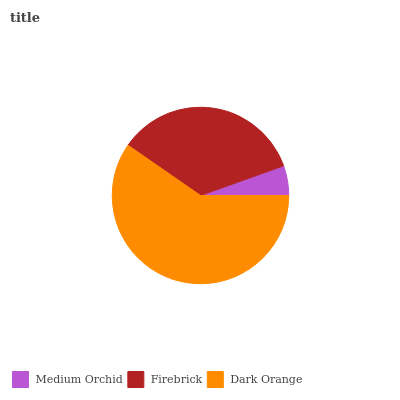Is Medium Orchid the minimum?
Answer yes or no. Yes. Is Dark Orange the maximum?
Answer yes or no. Yes. Is Firebrick the minimum?
Answer yes or no. No. Is Firebrick the maximum?
Answer yes or no. No. Is Firebrick greater than Medium Orchid?
Answer yes or no. Yes. Is Medium Orchid less than Firebrick?
Answer yes or no. Yes. Is Medium Orchid greater than Firebrick?
Answer yes or no. No. Is Firebrick less than Medium Orchid?
Answer yes or no. No. Is Firebrick the high median?
Answer yes or no. Yes. Is Firebrick the low median?
Answer yes or no. Yes. Is Dark Orange the high median?
Answer yes or no. No. Is Dark Orange the low median?
Answer yes or no. No. 